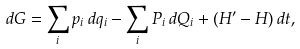<formula> <loc_0><loc_0><loc_500><loc_500>d G = \sum _ { i } p _ { i } \, d q _ { i } - \sum _ { i } P _ { i } \, d Q _ { i } + ( H ^ { \prime } - H ) \, d t ,</formula> 